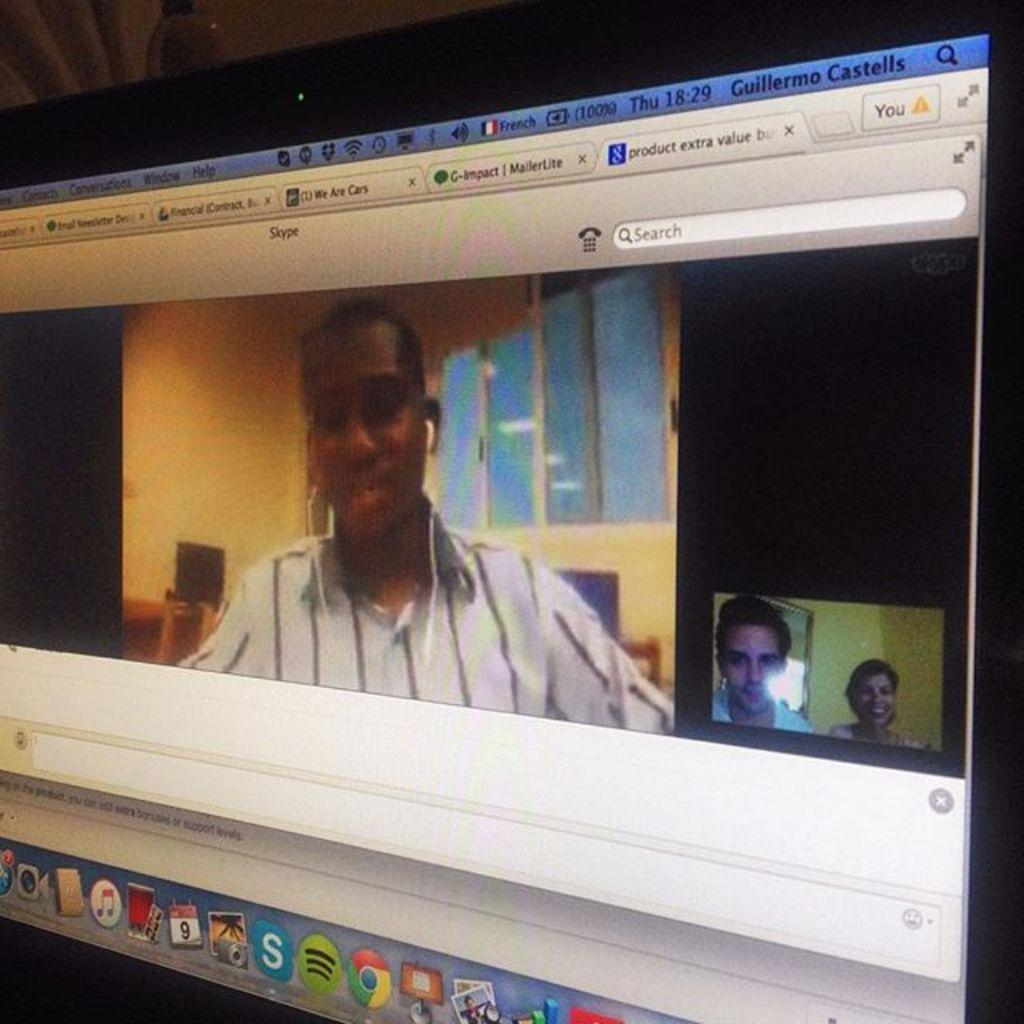What is the main object in the image? There is a monitor screen in the image. What are the people in the image doing with the monitor screen? People are doing FaceTime on the monitor screen. What type of line is visible on the monitor screen during the FaceTime call? There is no line visible on the monitor screen during the FaceTime call in the image. 